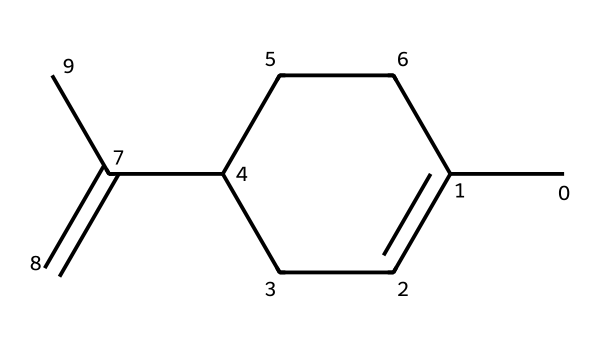What is the total number of carbon atoms in limonene? By examining the SMILES representation CC1=CCC(CC1)C(=C)C, we can count the carbon atoms represented in the structure. The count reveals 10 carbon atoms in total.
Answer: 10 How many double bonds are present in this compound? In the SMILES structure CC1=CCC(CC1)C(=C)C, there are two '=' symbols, indicating the presence of two double bonds in the chemical structure.
Answer: 2 What type of compound is limonene classified as? Limonene is primarily classified as a terpene which is a type of aliphatic compound. This classification is based on its structure and general properties associated with terpene compounds.
Answer: terpene Are there any rings present in this structure? The SMILES representation reveals that the 'C1' notation indicates that there is a cyclic structure. Thus, the presence of such notation confirms the existence of a ring in the molecule.
Answer: yes What is the functional group present in limonene? The structure of limonene contains a double bond, which indicates that it belongs to alkenes, a specific type of functional group in organic compounds.
Answer: alkene What molecular feature gives limonene its citrus scent? The presence of the specific arrangement and types of bonds, particularly as a cyclic and unsaturated compound (due to the double bonds), contribute to the aroma, making it characteristic of citrus compounds.
Answer: cyclic and unsaturated structure Does limonene have any chiral centers? By closely analyzing the structure from the SMILES, it can be observed that there are specific carbon atoms bonded to four different substituents, indicating that limonene does indeed have chiral centers.
Answer: yes 